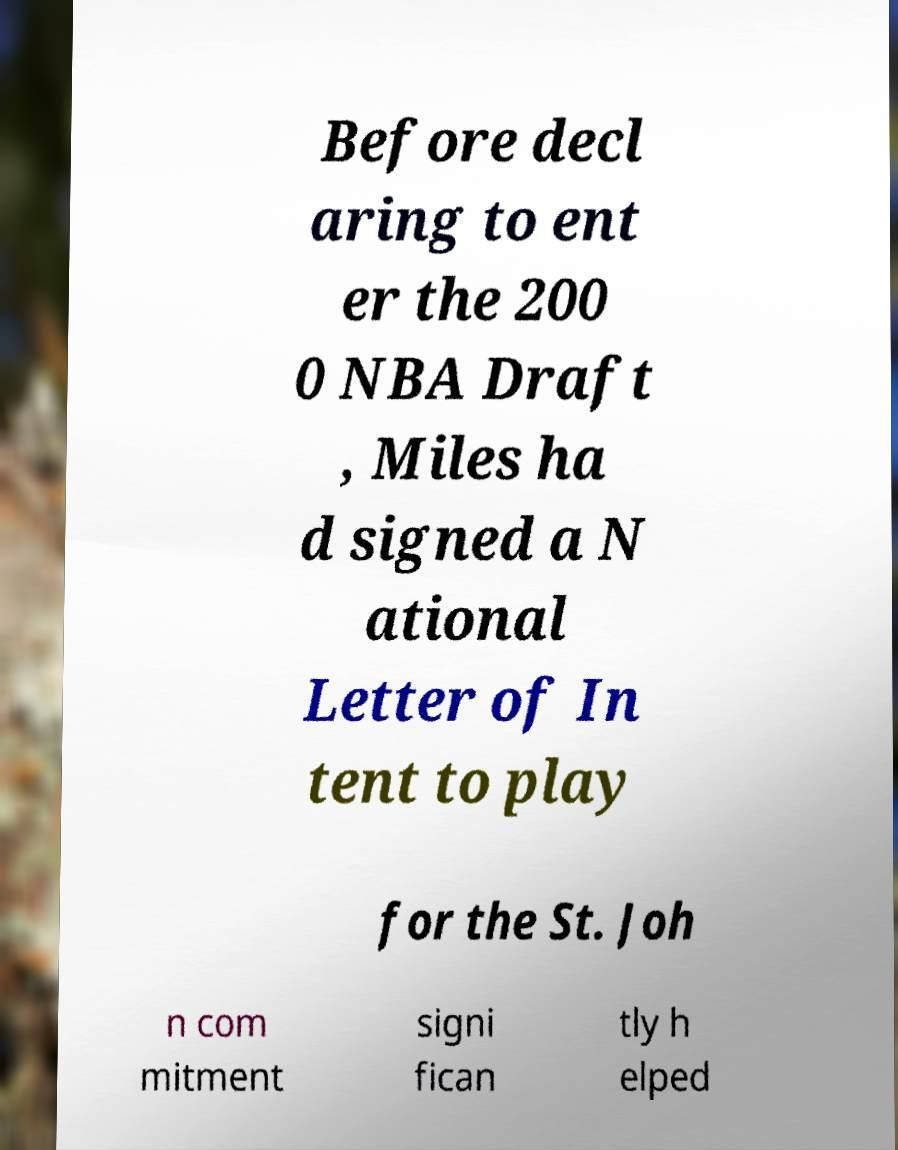For documentation purposes, I need the text within this image transcribed. Could you provide that? Before decl aring to ent er the 200 0 NBA Draft , Miles ha d signed a N ational Letter of In tent to play for the St. Joh n com mitment signi fican tly h elped 